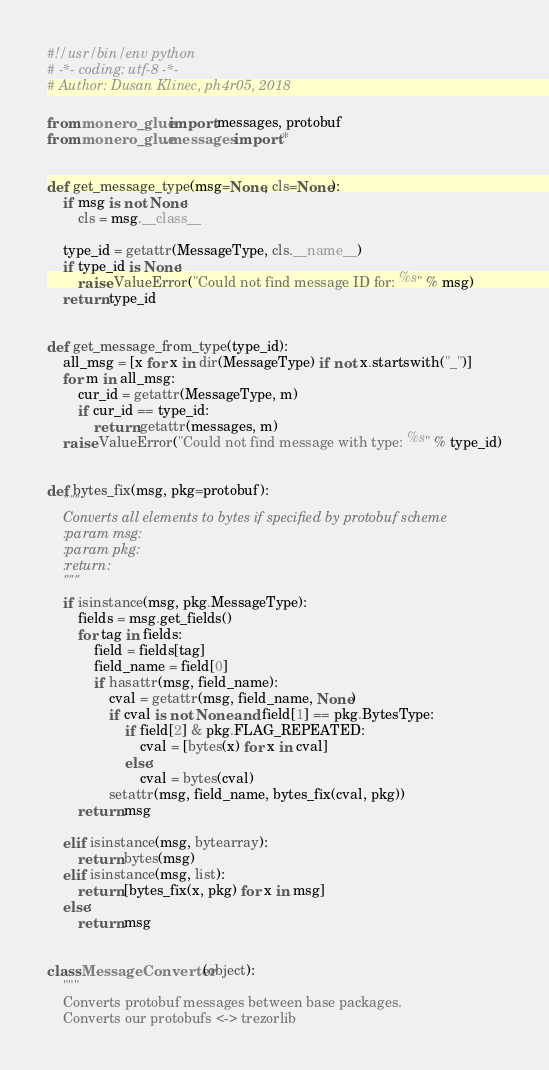Convert code to text. <code><loc_0><loc_0><loc_500><loc_500><_Python_>#!/usr/bin/env python
# -*- coding: utf-8 -*-
# Author: Dusan Klinec, ph4r05, 2018

from monero_glue import messages, protobuf
from monero_glue.messages import *


def get_message_type(msg=None, cls=None):
    if msg is not None:
        cls = msg.__class__

    type_id = getattr(MessageType, cls.__name__)
    if type_id is None:
        raise ValueError("Could not find message ID for: %s" % msg)
    return type_id


def get_message_from_type(type_id):
    all_msg = [x for x in dir(MessageType) if not x.startswith("_")]
    for m in all_msg:
        cur_id = getattr(MessageType, m)
        if cur_id == type_id:
            return getattr(messages, m)
    raise ValueError("Could not find message with type: %s" % type_id)


def bytes_fix(msg, pkg=protobuf):
    """
    Converts all elements to bytes if specified by protobuf scheme
    :param msg:
    :param pkg:
    :return:
    """
    if isinstance(msg, pkg.MessageType):
        fields = msg.get_fields()
        for tag in fields:
            field = fields[tag]
            field_name = field[0]
            if hasattr(msg, field_name):
                cval = getattr(msg, field_name, None)
                if cval is not None and field[1] == pkg.BytesType:
                    if field[2] & pkg.FLAG_REPEATED:
                        cval = [bytes(x) for x in cval]
                    else:
                        cval = bytes(cval)
                setattr(msg, field_name, bytes_fix(cval, pkg))
        return msg

    elif isinstance(msg, bytearray):
        return bytes(msg)
    elif isinstance(msg, list):
        return [bytes_fix(x, pkg) for x in msg]
    else:
        return msg


class MessageConverter(object):
    """
    Converts protobuf messages between base packages.
    Converts our protobufs <-> trezorlib</code> 